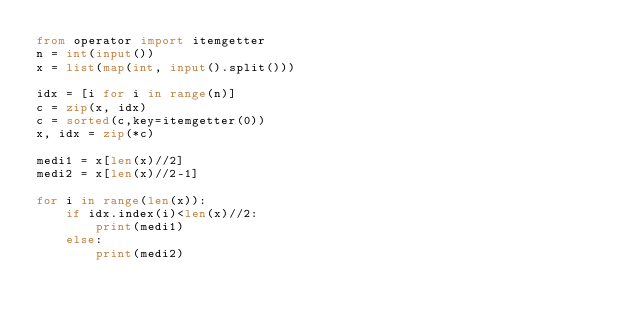Convert code to text. <code><loc_0><loc_0><loc_500><loc_500><_Python_>from operator import itemgetter
n = int(input())
x = list(map(int, input().split()))

idx = [i for i in range(n)]
c = zip(x, idx)
c = sorted(c,key=itemgetter(0))
x, idx = zip(*c)

medi1 = x[len(x)//2]
medi2 = x[len(x)//2-1]

for i in range(len(x)):
    if idx.index(i)<len(x)//2:
        print(medi1)
    else:
        print(medi2)</code> 